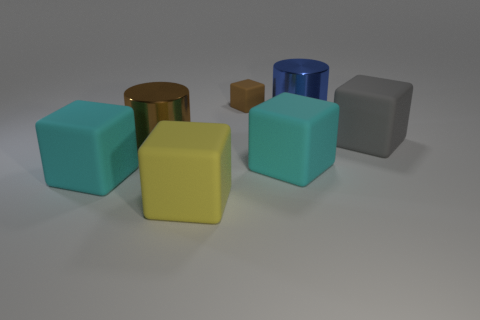There is a cylinder that is on the left side of the yellow rubber object; does it have the same color as the small matte block?
Offer a terse response. Yes. Does the large blue thing have the same material as the brown cylinder?
Provide a succinct answer. Yes. Are there an equal number of cyan objects right of the large blue cylinder and small brown rubber objects on the left side of the big brown metallic object?
Make the answer very short. Yes. What is the material of the brown object that is the same shape as the yellow matte thing?
Make the answer very short. Rubber. What is the shape of the shiny thing that is behind the cube right of the big shiny object on the right side of the tiny brown object?
Offer a very short reply. Cylinder. Are there more metal objects to the left of the large yellow block than green balls?
Ensure brevity in your answer.  Yes. Is the shape of the rubber thing on the right side of the blue cylinder the same as  the small object?
Ensure brevity in your answer.  Yes. What is the big cyan object right of the tiny brown rubber thing made of?
Provide a succinct answer. Rubber. What number of blue shiny things have the same shape as the big brown metal thing?
Provide a succinct answer. 1. The cylinder that is on the right side of the large metallic object left of the tiny object is made of what material?
Provide a short and direct response. Metal. 